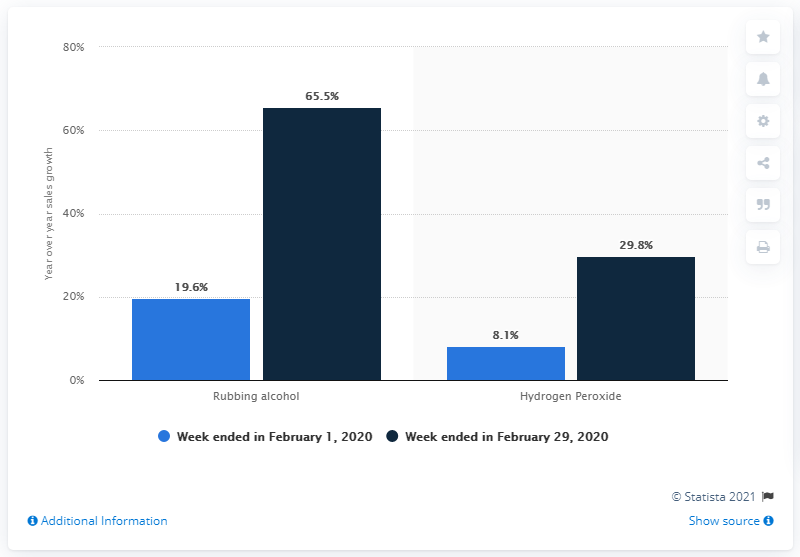Mention a couple of crucial points in this snapshot. The sales value of rubbing alcohol increased by 65.5% in the week ended February 29, 2020. 